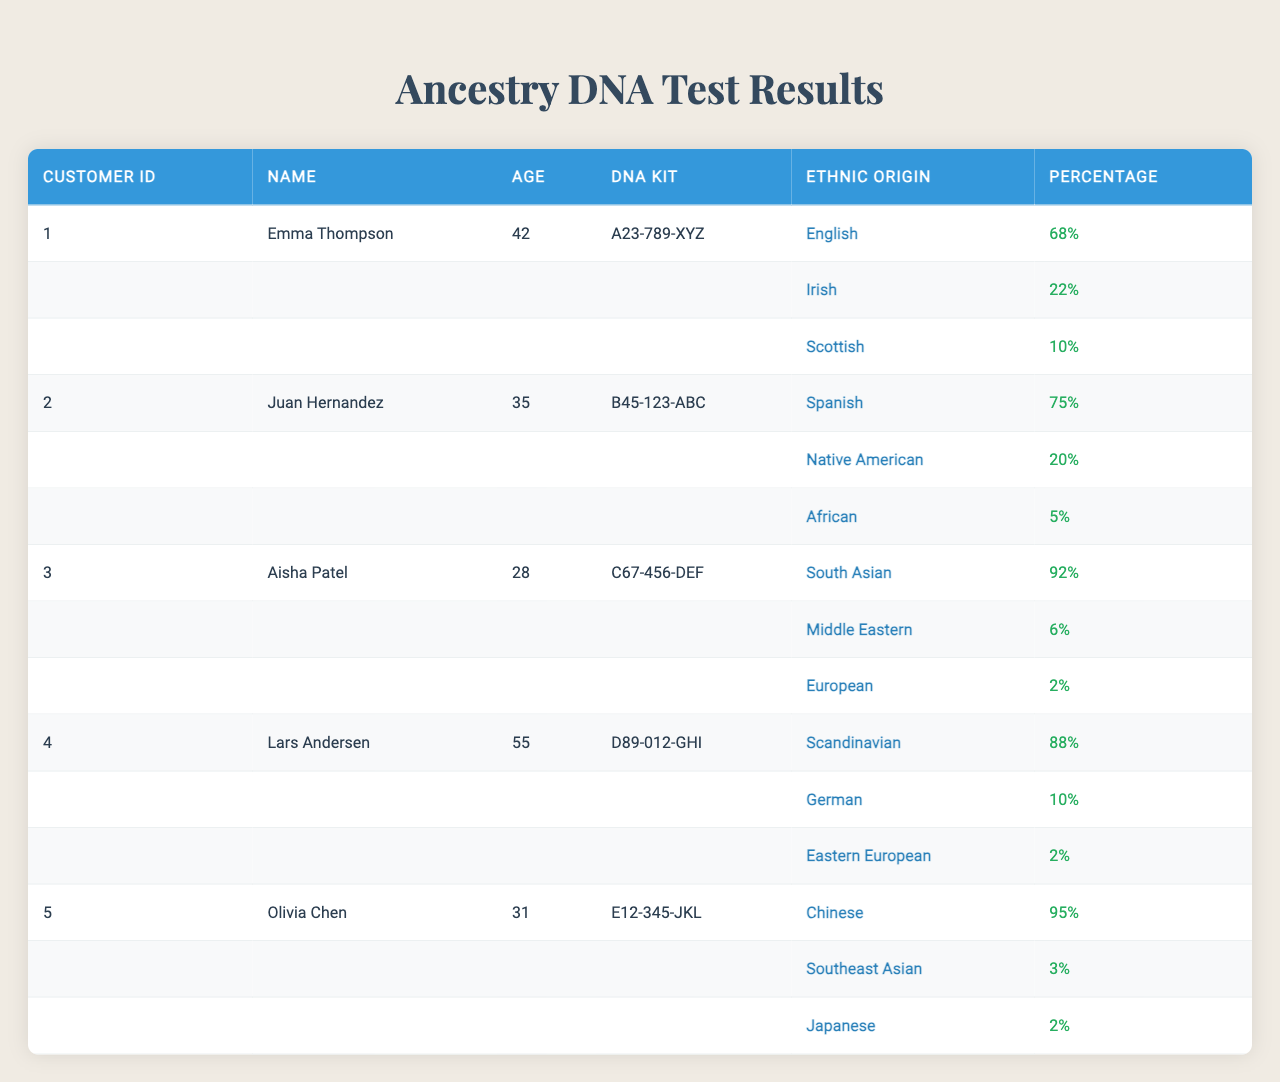What is the ethnic origin with the highest percentage for Emma Thompson? For Emma Thompson, the ethnic origins listed are English with 68%, Irish with 22%, and Scottish with 10%. The highest percentage is 68%.
Answer: English How many ethnic origins does Juan Hernandez have listed? Juan Hernandez has three ethnic origins listed: Spanish (75%), Native American (20%), and African (5%). The count is three.
Answer: 3 Is Olivia Chen's ancestry mostly Asian? Olivia Chen's ethnic origins include Chinese (95%), Southeast Asian (3%), and Japanese (2%). With 95%, most of her ancestry is indeed Asian.
Answer: Yes What is the average age of the customers shown in the table? The ages of the customers are 42 (Emma), 35 (Juan), 28 (Aisha), 55 (Lars), and 31 (Olivia). To find the average: (42 + 35 + 28 + 55 + 31) = 191, and there are 5 customers, so 191 / 5 = 38.2.
Answer: 38.2 Which ethnic origin represents a larger percentage for Aisha Patel, South Asian or Middle Eastern? Aisha Patel’s ethnic origins show South Asian at 92% and Middle Eastern at 6%. Therefore, South Asian represents a significantly larger percentage.
Answer: South Asian What is the total percentage of the three ethnic origins for Lars Andersen? For Lars Andersen, the ethnic origins are Scandinavian (88%), German (10%), and Eastern European (2%). Adding these up gives 88 + 10 + 2 = 100%.
Answer: 100% Among the listed customers, who has the highest percentage of Native American ancestry? Juan Hernandez has 20% Native American, while no other listed customer has any percentage of Native American. Therefore, he has the highest.
Answer: Juan Hernandez Is the percentage of European ancestry for Aisha Patel significant compared to her other ancestries? Aisha Patel has South Asian (92%), Middle Eastern (6%), and European (2%). The European ancestry is significantly less compared to her other ancestries.
Answer: No What is the difference in percentage between Olivia Chen's highest and lowest ethnic origins? Olivia’s origins have Chinese at 95%, Southeast Asian at 3%, and Japanese at 2%. The difference between the highest (95%) and lowest (2%) is 95 - 2 = 93.
Answer: 93 Which customer has the most diverse ancestry based on the percentages given? To determine diversity, we compare the percentages: Emma has 3 origins, Juan has 3, Aisha has 3, Lars has 3, and Olivia has 3, but the highest percentage (more than 90%) for Olivia suggests less diversity in ancestry. Each customer has equal diversity with three origins listed.
Answer: All are equally diverse 